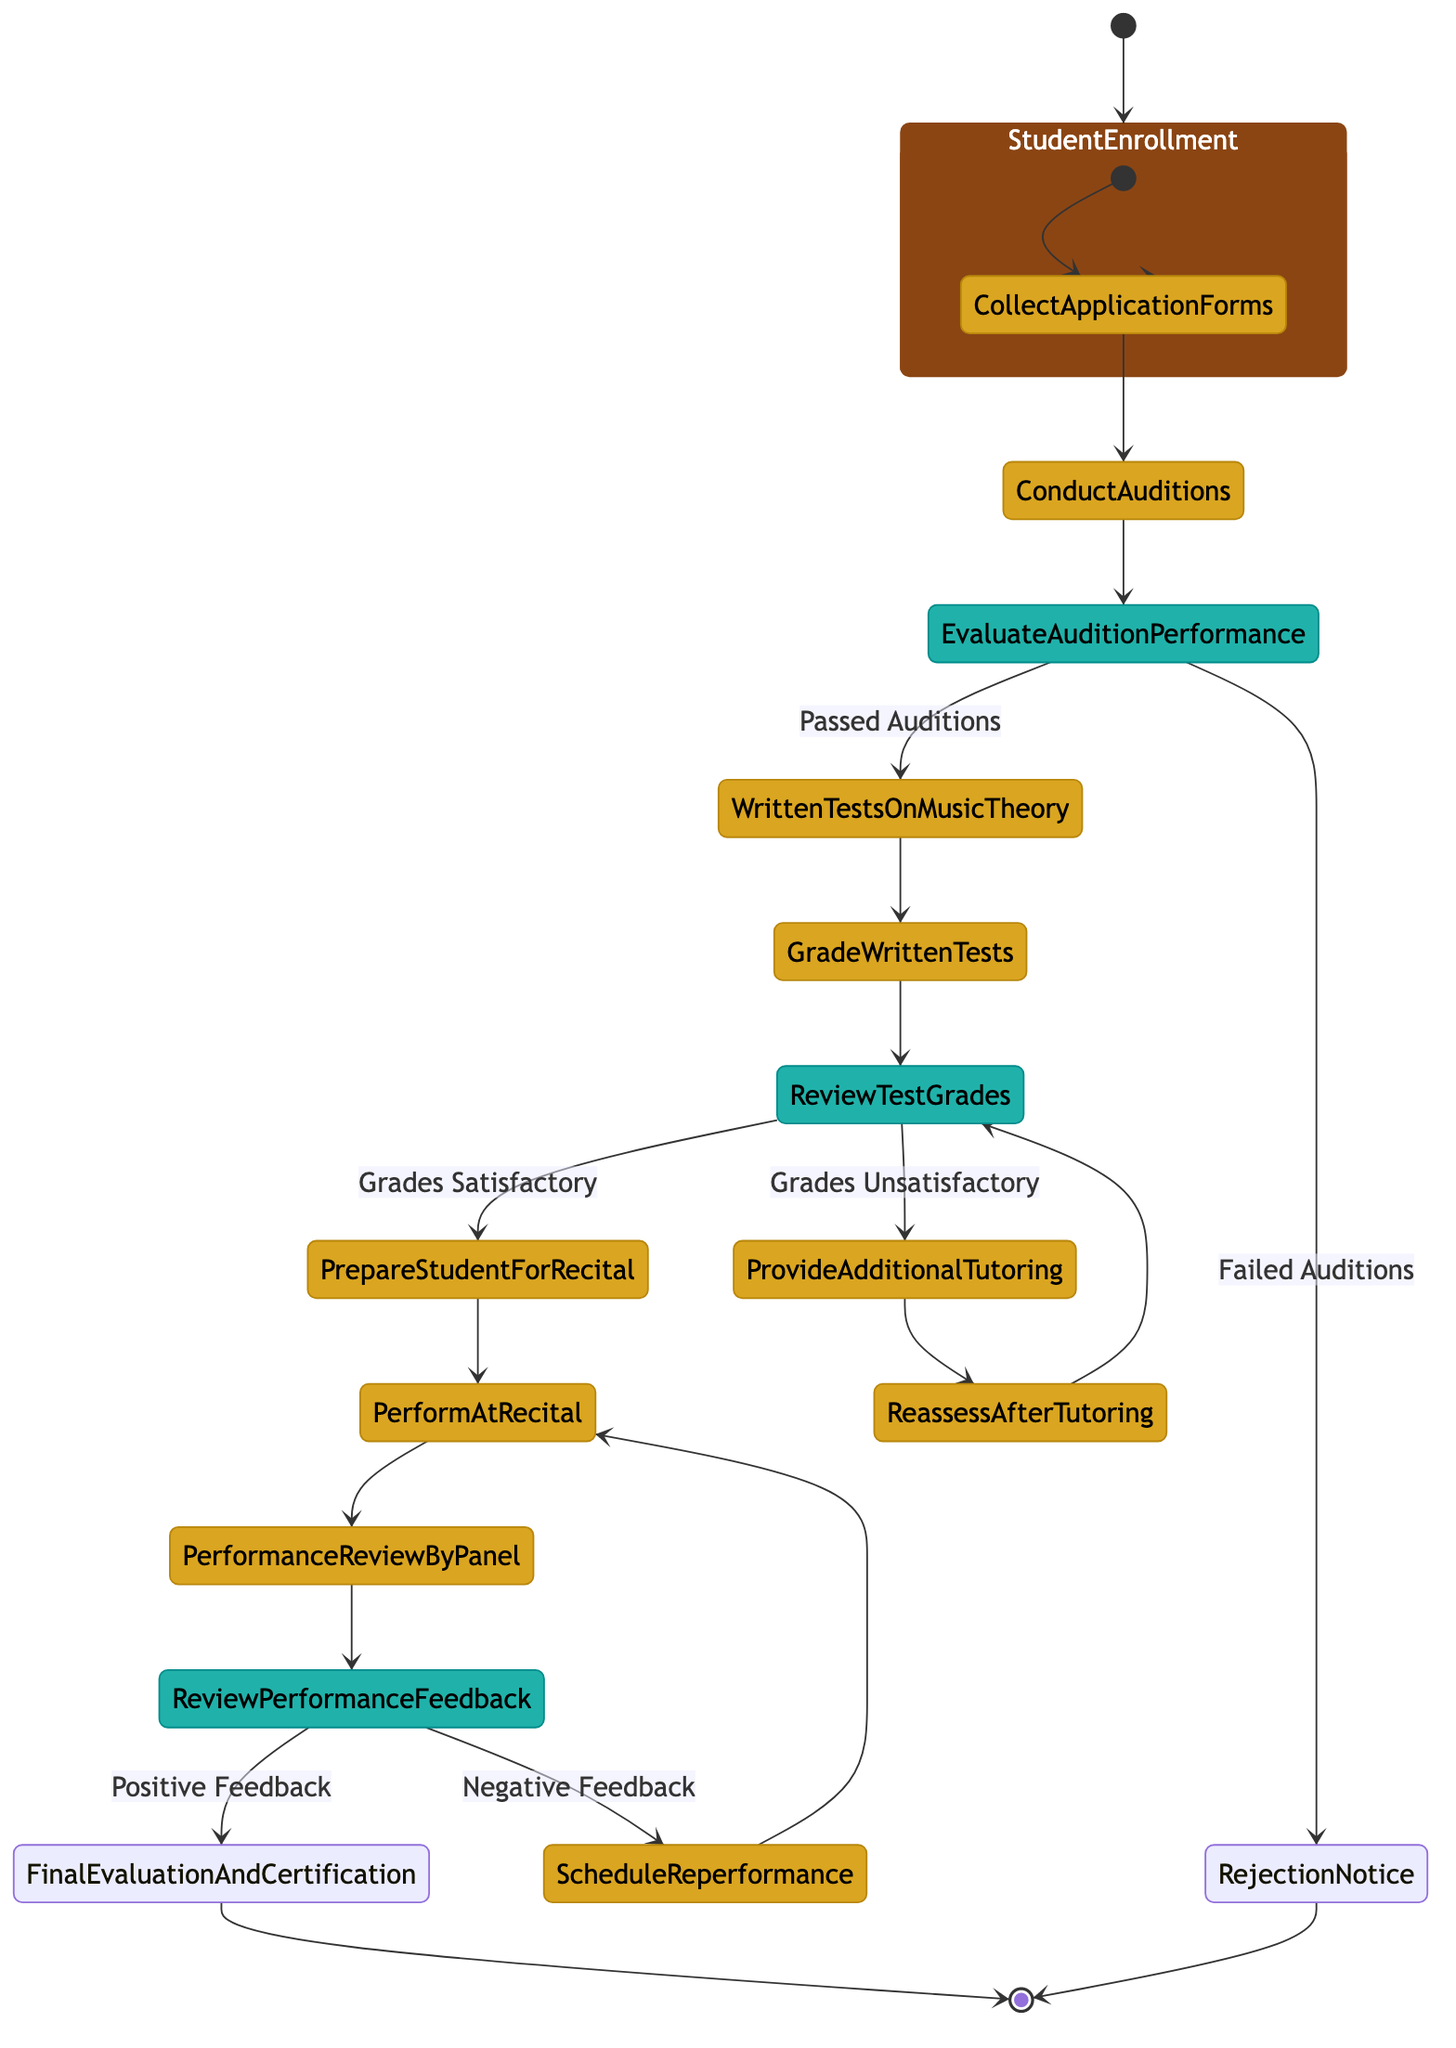What is the starting point of the evaluation process? The evaluation process begins at the "Student Enrollment" node, which is the initial node in the diagram indicating where the process starts.
Answer: Student Enrollment How many final nodes are there in the diagram? The diagram has two final nodes: "Rejection Notice" and "Final Evaluation and Certification," indicating two distinct end points of the process.
Answer: 2 What happens if the student passes the auditions? If the student passes the auditions, the process moves to "Written Tests on Music Theory," where the next action takes place.
Answer: Written Tests on Music Theory What are the options after grading written tests? After grading written tests, the decision branches into two options: either "Prepare Student for Recital" if grades are satisfactory or "Provide Additional Tutoring" if grades are unsatisfactory.
Answer: Prepare Student for Recital, Provide Additional Tutoring What occurs when performance feedback is negative? If the performance feedback is negative, the process cycles back to "Schedule Re-performance," which allows the student another chance to perform.
Answer: Schedule Re-performance What is the decision point after auditions evaluate performance? The decision point after evaluating audition performance assesses whether the student has "Passed Auditions" or "Failed Auditions." Based on this, the next step in the process is determined.
Answer: Evaluate Audition Performance How many actions are performed after the student is prepared for recital? After preparing the student for the recital, there are two subsequent actions: "Perform at Recital" and then "Performance Review by Panel," indicating a direct sequence.
Answer: 2 What happens if the student's test grades are unsatisfactory? If the student's test grades are unsatisfactory, they receive "Provide Additional Tutoring" as the next action, indicating that more support is needed before moving forward.
Answer: Provide Additional Tutoring 